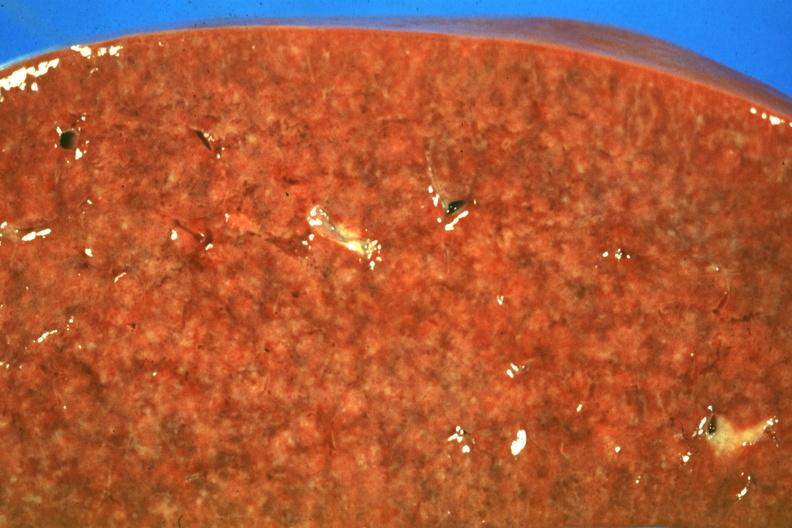what does this image show?
Answer the question using a single word or phrase. Cut surface granulomas faint but there 